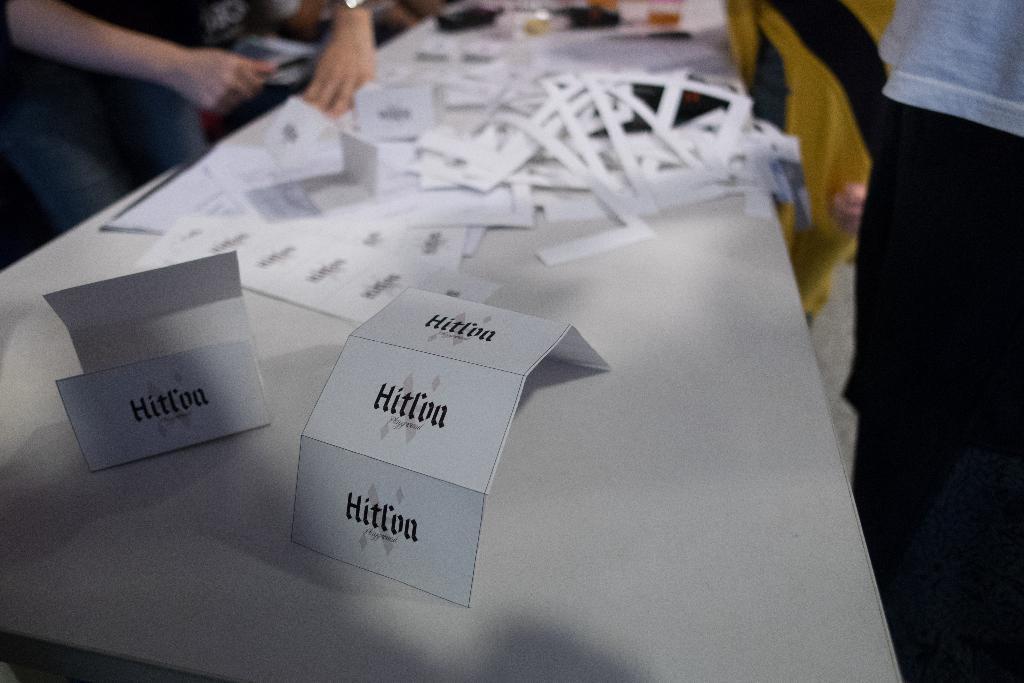Could you give a brief overview of what you see in this image? There are cards, papers and other objects on a table. We can see few persons are standing on the left and right side. 